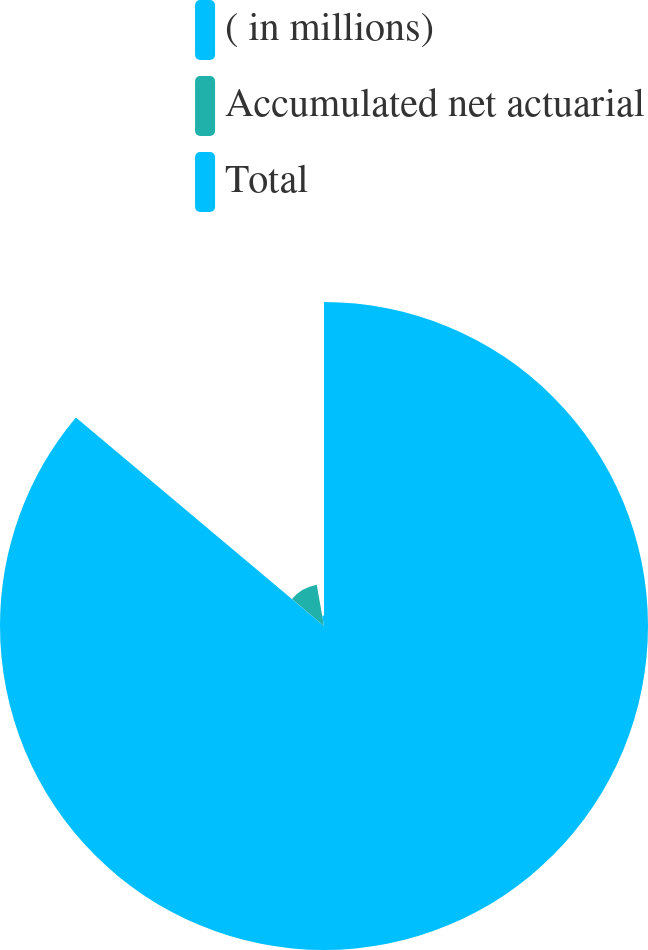Convert chart to OTSL. <chart><loc_0><loc_0><loc_500><loc_500><pie_chart><fcel>( in millions)<fcel>Accumulated net actuarial<fcel>Total<nl><fcel>86.12%<fcel>11.11%<fcel>2.77%<nl></chart> 